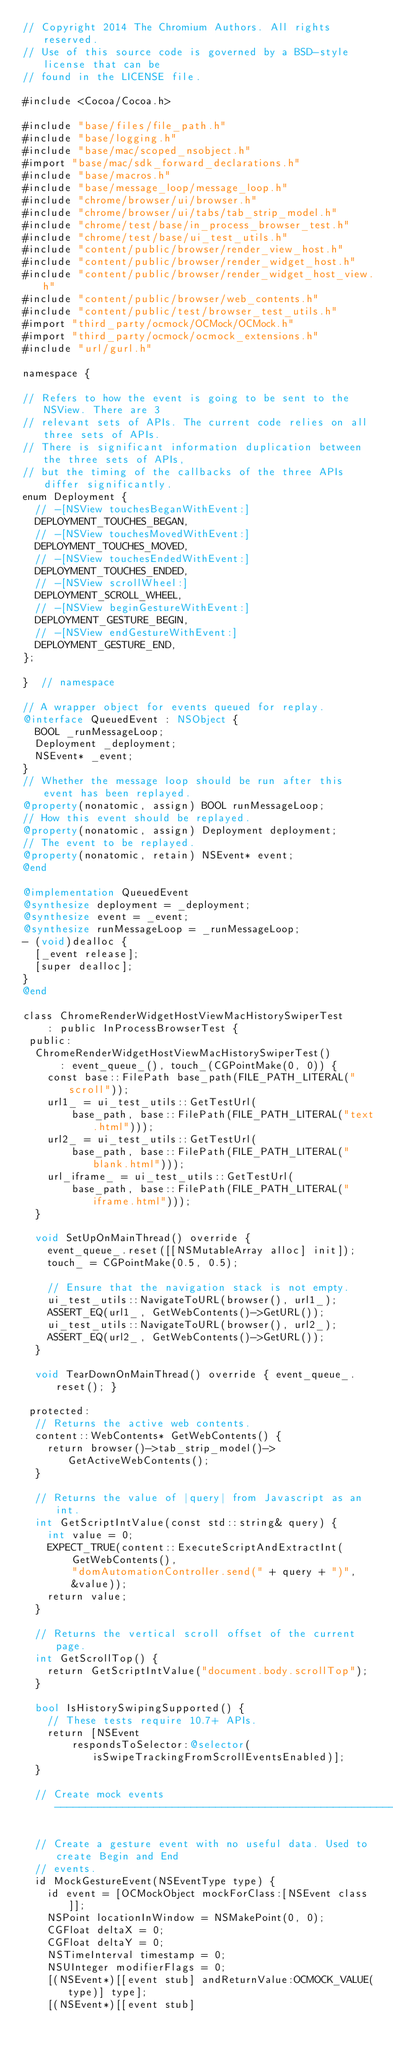<code> <loc_0><loc_0><loc_500><loc_500><_ObjectiveC_>// Copyright 2014 The Chromium Authors. All rights reserved.
// Use of this source code is governed by a BSD-style license that can be
// found in the LICENSE file.

#include <Cocoa/Cocoa.h>

#include "base/files/file_path.h"
#include "base/logging.h"
#include "base/mac/scoped_nsobject.h"
#import "base/mac/sdk_forward_declarations.h"
#include "base/macros.h"
#include "base/message_loop/message_loop.h"
#include "chrome/browser/ui/browser.h"
#include "chrome/browser/ui/tabs/tab_strip_model.h"
#include "chrome/test/base/in_process_browser_test.h"
#include "chrome/test/base/ui_test_utils.h"
#include "content/public/browser/render_view_host.h"
#include "content/public/browser/render_widget_host.h"
#include "content/public/browser/render_widget_host_view.h"
#include "content/public/browser/web_contents.h"
#include "content/public/test/browser_test_utils.h"
#import "third_party/ocmock/OCMock/OCMock.h"
#import "third_party/ocmock/ocmock_extensions.h"
#include "url/gurl.h"

namespace {

// Refers to how the event is going to be sent to the NSView. There are 3
// relevant sets of APIs. The current code relies on all three sets of APIs.
// There is significant information duplication between the three sets of APIs,
// but the timing of the callbacks of the three APIs differ significantly.
enum Deployment {
  // -[NSView touchesBeganWithEvent:]
  DEPLOYMENT_TOUCHES_BEGAN,
  // -[NSView touchesMovedWithEvent:]
  DEPLOYMENT_TOUCHES_MOVED,
  // -[NSView touchesEndedWithEvent:]
  DEPLOYMENT_TOUCHES_ENDED,
  // -[NSView scrollWheel:]
  DEPLOYMENT_SCROLL_WHEEL,
  // -[NSView beginGestureWithEvent:]
  DEPLOYMENT_GESTURE_BEGIN,
  // -[NSView endGestureWithEvent:]
  DEPLOYMENT_GESTURE_END,
};

}  // namespace

// A wrapper object for events queued for replay.
@interface QueuedEvent : NSObject {
  BOOL _runMessageLoop;
  Deployment _deployment;
  NSEvent* _event;
}
// Whether the message loop should be run after this event has been replayed.
@property(nonatomic, assign) BOOL runMessageLoop;
// How this event should be replayed.
@property(nonatomic, assign) Deployment deployment;
// The event to be replayed.
@property(nonatomic, retain) NSEvent* event;
@end

@implementation QueuedEvent
@synthesize deployment = _deployment;
@synthesize event = _event;
@synthesize runMessageLoop = _runMessageLoop;
- (void)dealloc {
  [_event release];
  [super dealloc];
}
@end

class ChromeRenderWidgetHostViewMacHistorySwiperTest
    : public InProcessBrowserTest {
 public:
  ChromeRenderWidgetHostViewMacHistorySwiperTest()
      : event_queue_(), touch_(CGPointMake(0, 0)) {
    const base::FilePath base_path(FILE_PATH_LITERAL("scroll"));
    url1_ = ui_test_utils::GetTestUrl(
        base_path, base::FilePath(FILE_PATH_LITERAL("text.html")));
    url2_ = ui_test_utils::GetTestUrl(
        base_path, base::FilePath(FILE_PATH_LITERAL("blank.html")));
    url_iframe_ = ui_test_utils::GetTestUrl(
        base_path, base::FilePath(FILE_PATH_LITERAL("iframe.html")));
  }

  void SetUpOnMainThread() override {
    event_queue_.reset([[NSMutableArray alloc] init]);
    touch_ = CGPointMake(0.5, 0.5);

    // Ensure that the navigation stack is not empty.
    ui_test_utils::NavigateToURL(browser(), url1_);
    ASSERT_EQ(url1_, GetWebContents()->GetURL());
    ui_test_utils::NavigateToURL(browser(), url2_);
    ASSERT_EQ(url2_, GetWebContents()->GetURL());
  }

  void TearDownOnMainThread() override { event_queue_.reset(); }

 protected:
  // Returns the active web contents.
  content::WebContents* GetWebContents() {
    return browser()->tab_strip_model()->GetActiveWebContents();
  }

  // Returns the value of |query| from Javascript as an int.
  int GetScriptIntValue(const std::string& query) {
    int value = 0;
    EXPECT_TRUE(content::ExecuteScriptAndExtractInt(
        GetWebContents(),
        "domAutomationController.send(" + query + ")",
        &value));
    return value;
  }

  // Returns the vertical scroll offset of the current page.
  int GetScrollTop() {
    return GetScriptIntValue("document.body.scrollTop");
  }

  bool IsHistorySwipingSupported() {
    // These tests require 10.7+ APIs.
    return [NSEvent
        respondsToSelector:@selector(isSwipeTrackingFromScrollEventsEnabled)];
  }

  // Create mock events --------------------------------------------------------

  // Create a gesture event with no useful data. Used to create Begin and End
  // events.
  id MockGestureEvent(NSEventType type) {
    id event = [OCMockObject mockForClass:[NSEvent class]];
    NSPoint locationInWindow = NSMakePoint(0, 0);
    CGFloat deltaX = 0;
    CGFloat deltaY = 0;
    NSTimeInterval timestamp = 0;
    NSUInteger modifierFlags = 0;
    [(NSEvent*)[[event stub] andReturnValue:OCMOCK_VALUE(type)] type];
    [(NSEvent*)[[event stub]</code> 